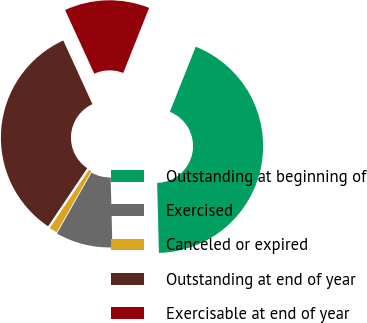Convert chart. <chart><loc_0><loc_0><loc_500><loc_500><pie_chart><fcel>Outstanding at beginning of<fcel>Exercised<fcel>Canceled or expired<fcel>Outstanding at end of year<fcel>Exercisable at end of year<nl><fcel>43.57%<fcel>8.62%<fcel>1.21%<fcel>33.73%<fcel>12.86%<nl></chart> 